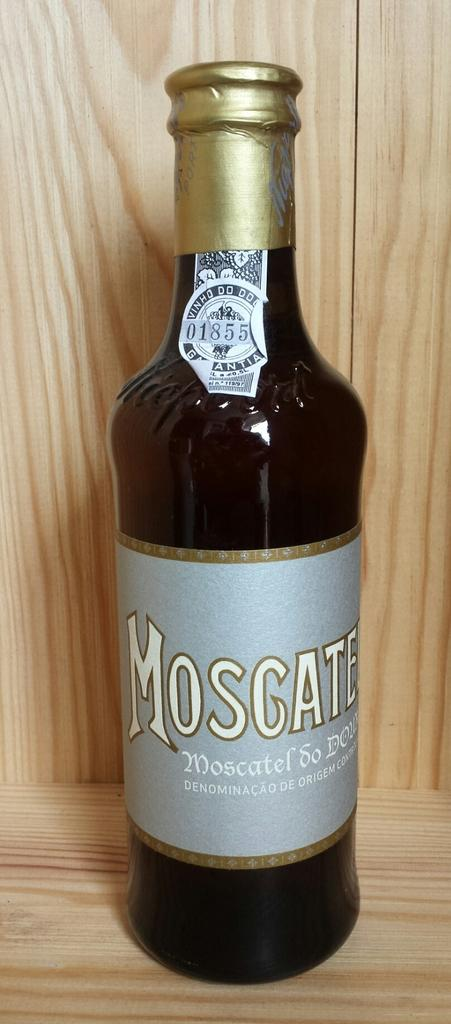Provide a one-sentence caption for the provided image. A glass bottle of Moscatel standing inside of a wooden cabinet. 